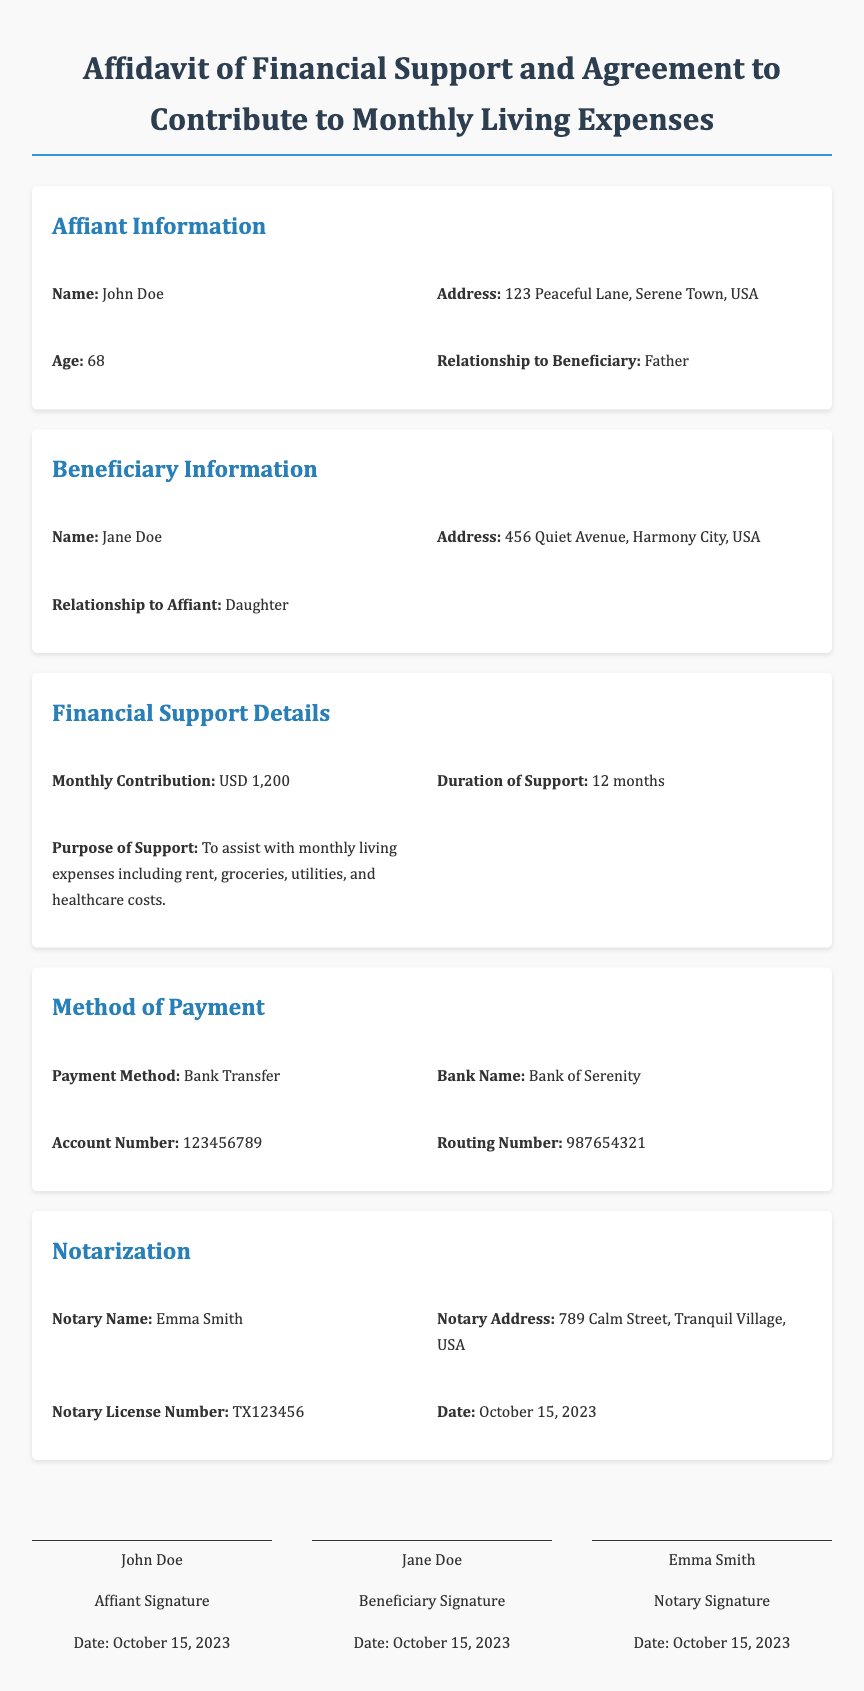What is the name of the affiant? The name of the affiant is indicated in the document under "Affiant Information."
Answer: John Doe What is the address of the beneficiary? The address of the beneficiary is noted in the "Beneficiary Information" section.
Answer: 456 Quiet Avenue, Harmony City, USA How much monthly financial support is pledged? The pledged monthly support is specified in the "Financial Support Details" section.
Answer: USD 1,200 What is the duration of the financial support? The duration can be found in the "Financial Support Details" section as well.
Answer: 12 months What method of payment is agreed upon? The method of payment is detailed in the "Method of Payment" section.
Answer: Bank Transfer Who is the notary for this affidavit? The notary's name is provided in the "Notarization" section of the document.
Answer: Emma Smith What is the date of notarization? The notarization date is clearly stated in the "Notarization" section.
Answer: October 15, 2023 What relationship does the affiant have to the beneficiary? The relationship is listed in the "Affiant Information" section.
Answer: Father What is the purpose of the financial support? The purpose is outlined in the "Financial Support Details" section.
Answer: To assist with monthly living expenses including rent, groceries, utilities, and healthcare costs 